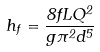Convert formula to latex. <formula><loc_0><loc_0><loc_500><loc_500>h _ { f } = \frac { 8 f L Q ^ { 2 } } { g \pi ^ { 2 } d ^ { 5 } }</formula> 